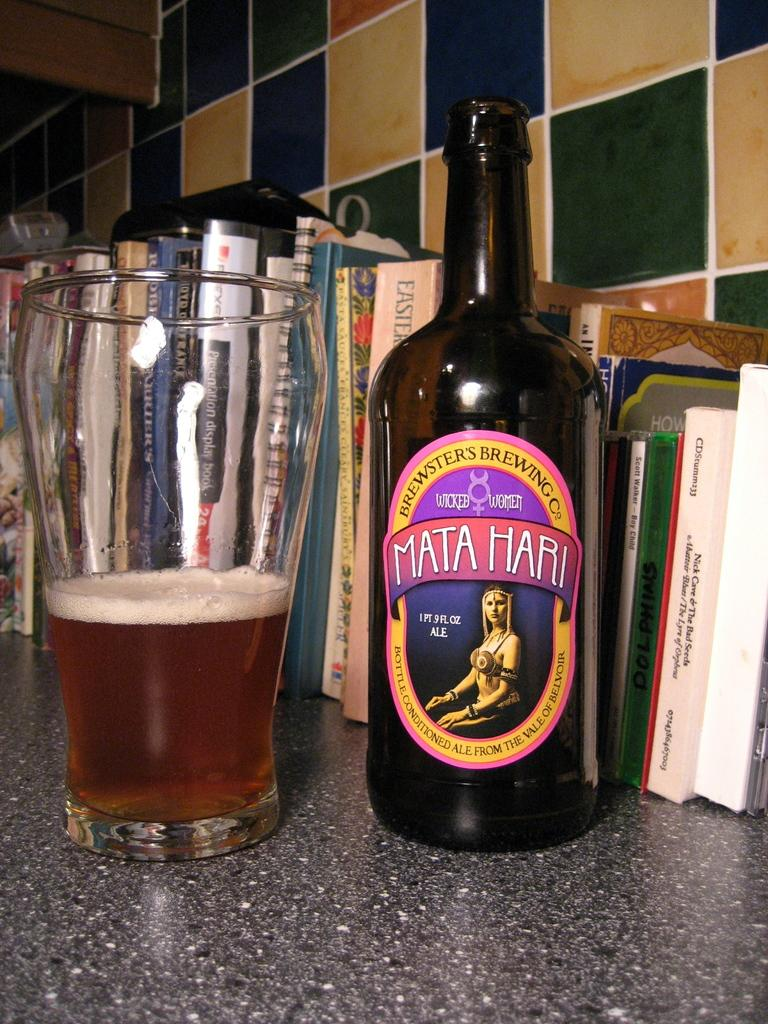What is in the glass that is visible in the image? There is a drink in the glass in the image. What else can be seen in the image besides the glass? There is a bottle and books placed in a line visible in the image. What is visible in the background of the image? There is a wall visible in the background of the image. How many girls are sitting on the crow in the image? There are no girls or crows present in the image. 